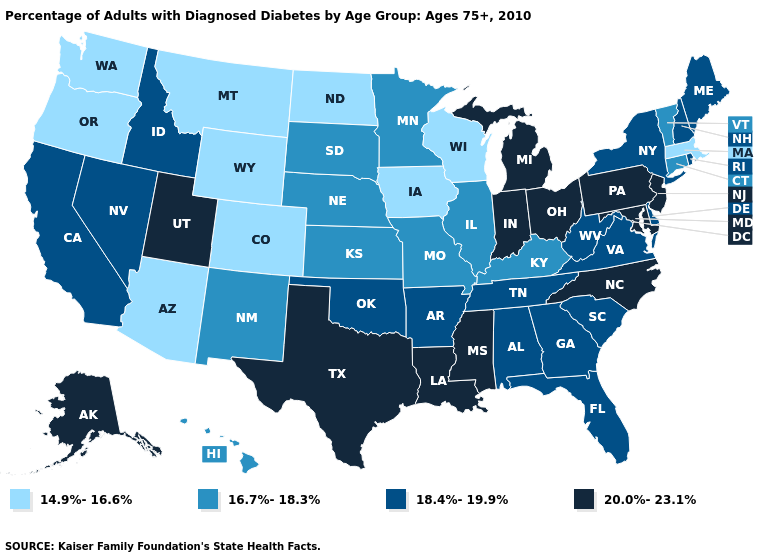What is the value of Pennsylvania?
Short answer required. 20.0%-23.1%. What is the lowest value in states that border Pennsylvania?
Concise answer only. 18.4%-19.9%. Does Michigan have a higher value than Mississippi?
Keep it brief. No. What is the value of Michigan?
Answer briefly. 20.0%-23.1%. What is the highest value in the USA?
Write a very short answer. 20.0%-23.1%. Which states have the highest value in the USA?
Give a very brief answer. Alaska, Indiana, Louisiana, Maryland, Michigan, Mississippi, New Jersey, North Carolina, Ohio, Pennsylvania, Texas, Utah. Does Massachusetts have the lowest value in the USA?
Concise answer only. Yes. Among the states that border Iowa , does Minnesota have the highest value?
Give a very brief answer. Yes. Which states have the lowest value in the USA?
Be succinct. Arizona, Colorado, Iowa, Massachusetts, Montana, North Dakota, Oregon, Washington, Wisconsin, Wyoming. What is the value of Montana?
Be succinct. 14.9%-16.6%. What is the highest value in the South ?
Quick response, please. 20.0%-23.1%. Among the states that border Tennessee , which have the highest value?
Give a very brief answer. Mississippi, North Carolina. What is the value of New Hampshire?
Give a very brief answer. 18.4%-19.9%. Does Ohio have the lowest value in the USA?
Be succinct. No. Name the states that have a value in the range 20.0%-23.1%?
Give a very brief answer. Alaska, Indiana, Louisiana, Maryland, Michigan, Mississippi, New Jersey, North Carolina, Ohio, Pennsylvania, Texas, Utah. 